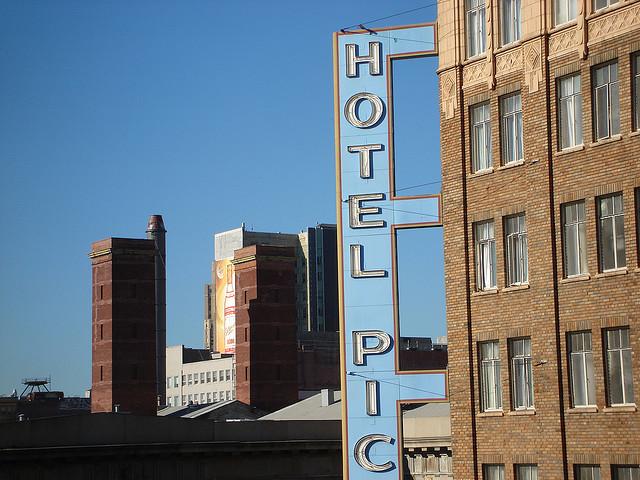What is the last letter of the first word on this sign?
Quick response, please. L. How many words do you see?
Quick response, please. 2. How many windows are on the right building?
Answer briefly. 20. 